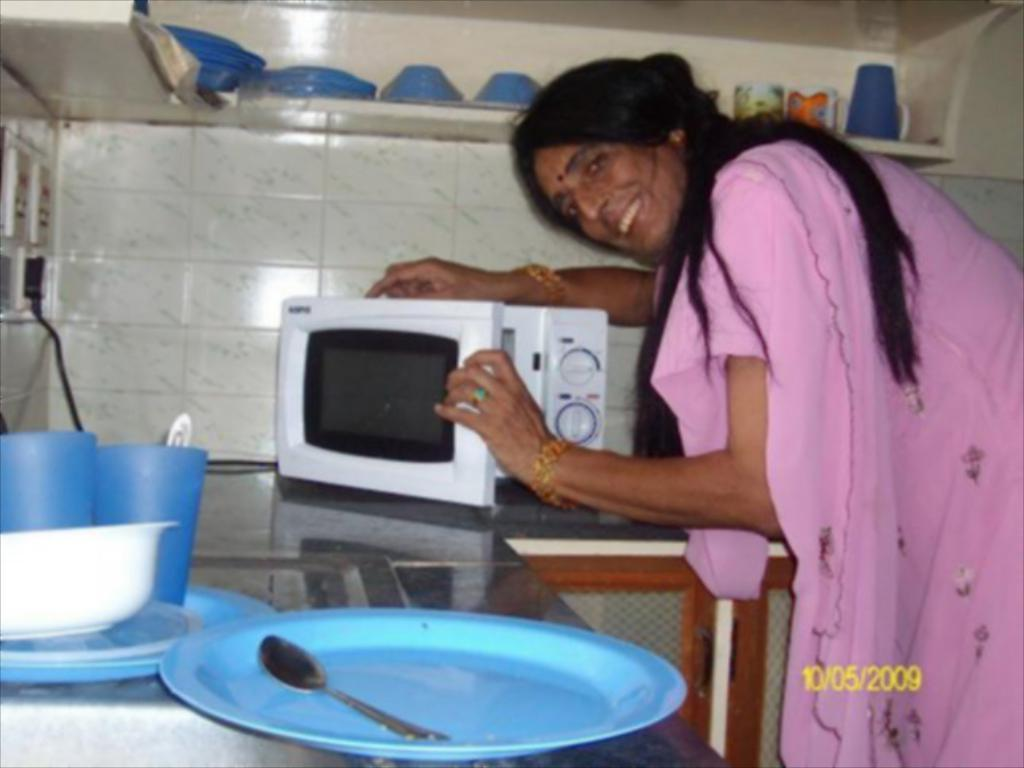What is the woman doing in the image? The woman is standing and smiling in the image. What kitchen appliance can be seen in the image? There is a microwave oven in the image. What type of dishware is present in the image? There are plates, a glass, a spoon, and a bowl in the image. What electrical component is visible in the image? There is a switchboard in the image. What type of wall is present in the image? There is a wall in the image. What type of storage is present in the image? There are cupboards in the image. What is on the shelf in the image? There are cups on the shelf, and some objects are also present. What type of addition problem can be solved using the objects on the shelf? There is no addition problem present in the image, as it is a scene of a woman in a kitchen with various objects. 